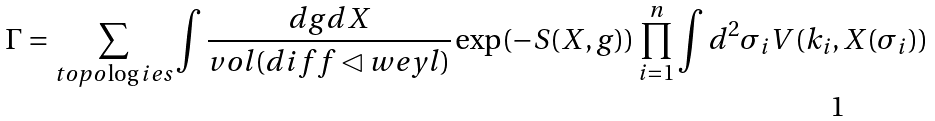<formula> <loc_0><loc_0><loc_500><loc_500>\Gamma = \sum _ { t o p o \log i e s } \int { \frac { d g d X } { v o l ( d i f f \lhd w e y l ) } \exp ( - S ( X , g ) ) \prod _ { i = 1 } ^ { n } \int { d ^ { 2 } \sigma _ { i } V ( k _ { i } , X ( \sigma _ { i } ) ) } }</formula> 